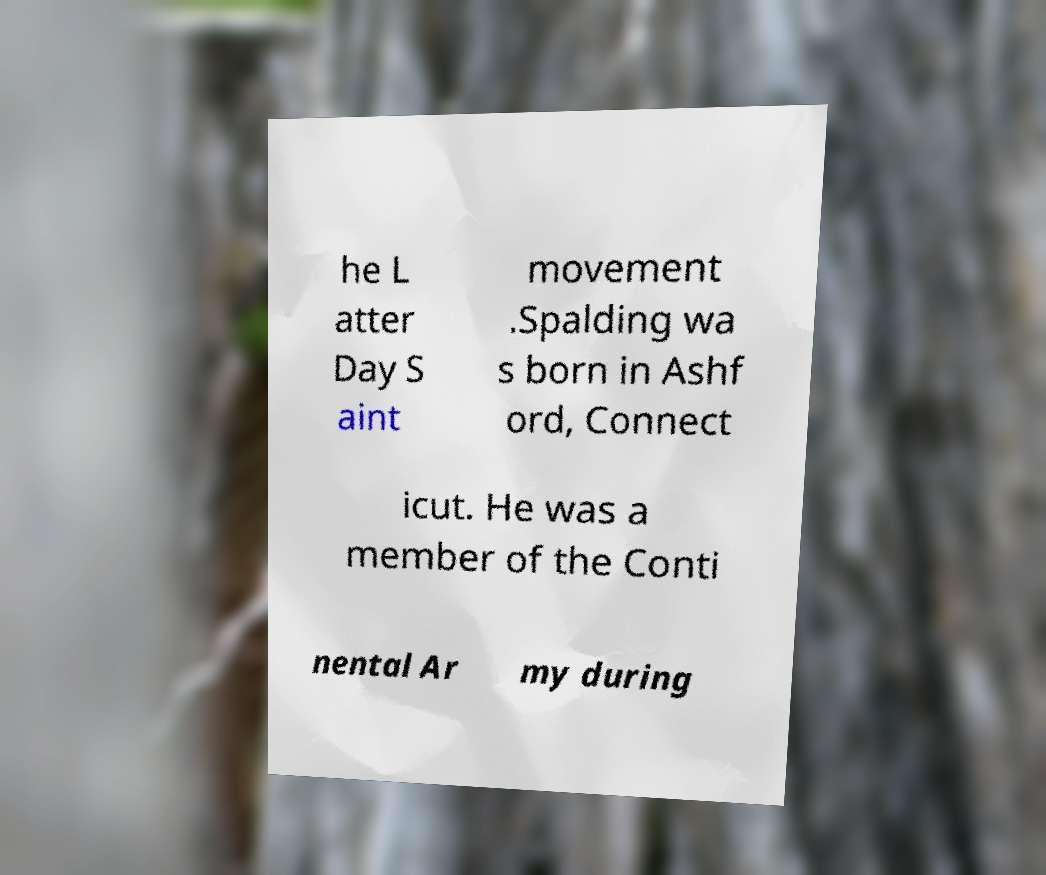For documentation purposes, I need the text within this image transcribed. Could you provide that? he L atter Day S aint movement .Spalding wa s born in Ashf ord, Connect icut. He was a member of the Conti nental Ar my during 